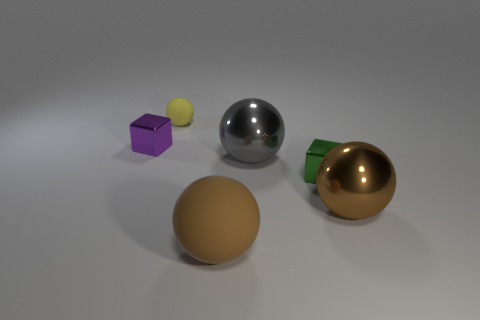What is the green object made of?
Keep it short and to the point. Metal. Do the large metal sphere that is right of the gray shiny thing and the matte thing that is on the right side of the small yellow ball have the same color?
Offer a very short reply. Yes. Is the number of small cubes that are in front of the small yellow ball greater than the number of large gray balls?
Provide a short and direct response. Yes. How many other things are there of the same color as the large matte object?
Offer a very short reply. 1. Is the size of the block right of the purple metallic thing the same as the tiny yellow matte thing?
Make the answer very short. Yes. Are there any cyan cubes that have the same size as the brown metal sphere?
Your answer should be compact. No. There is a matte thing behind the small purple metallic block; what color is it?
Offer a terse response. Yellow. What shape is the thing that is to the right of the gray metallic ball and behind the brown metal ball?
Your answer should be very brief. Cube. What number of big things are the same shape as the tiny purple object?
Provide a succinct answer. 0. How many big red rubber balls are there?
Ensure brevity in your answer.  0. 